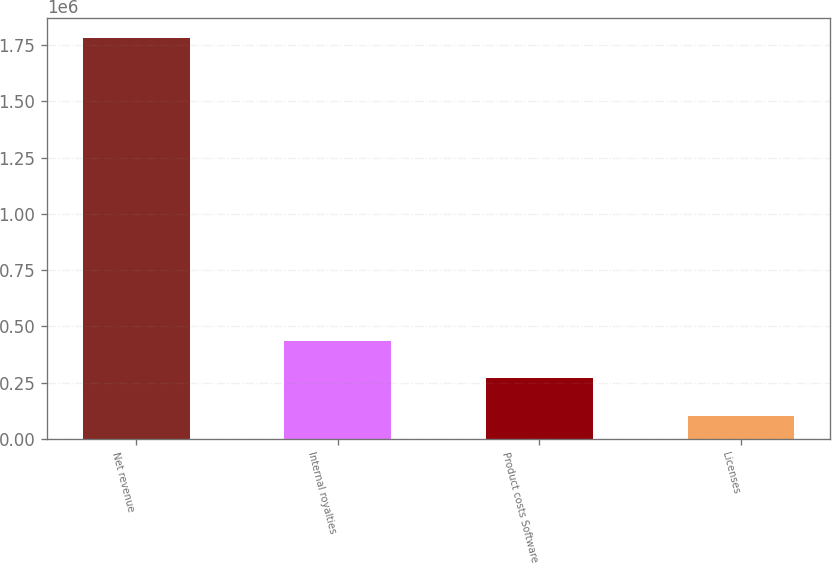Convert chart. <chart><loc_0><loc_0><loc_500><loc_500><bar_chart><fcel>Net revenue<fcel>Internal royalties<fcel>Product costs Software<fcel>Licenses<nl><fcel>1.77975e+06<fcel>436420<fcel>268504<fcel>100588<nl></chart> 